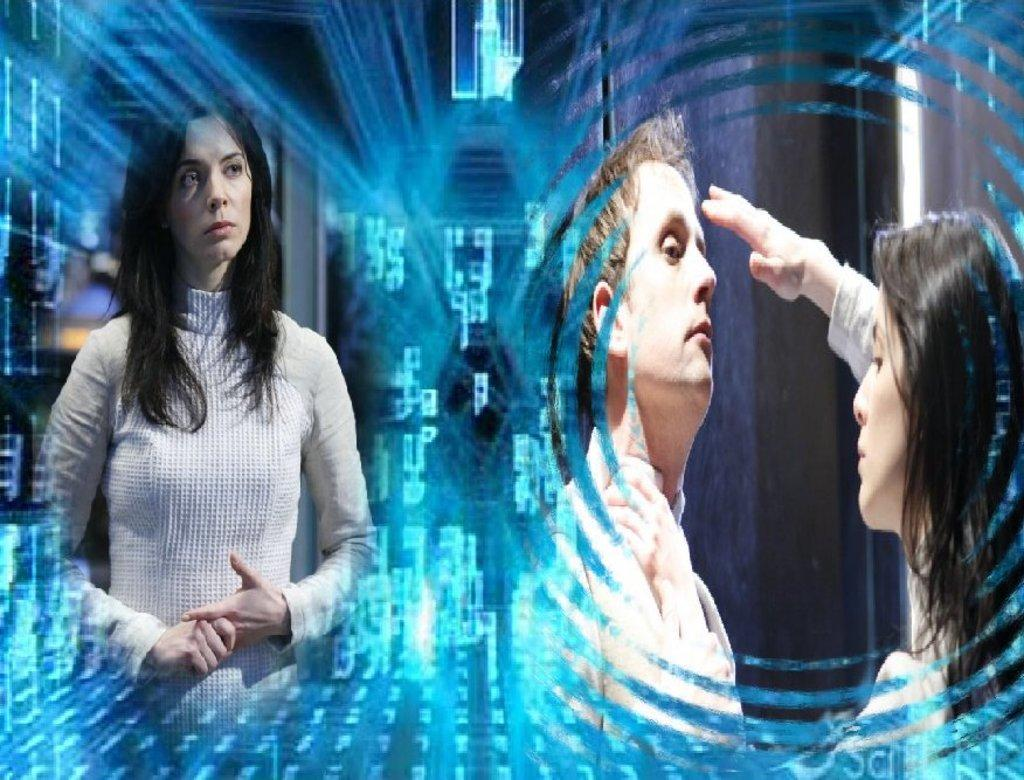How many people are present in the image? There are three people in the image. Where are the people located in the image? The people are on a path in the image. What can be seen in the background of the image? There are some other things in the background of the image. What type of head is visible on the path? There is no mention of a head in the image. 